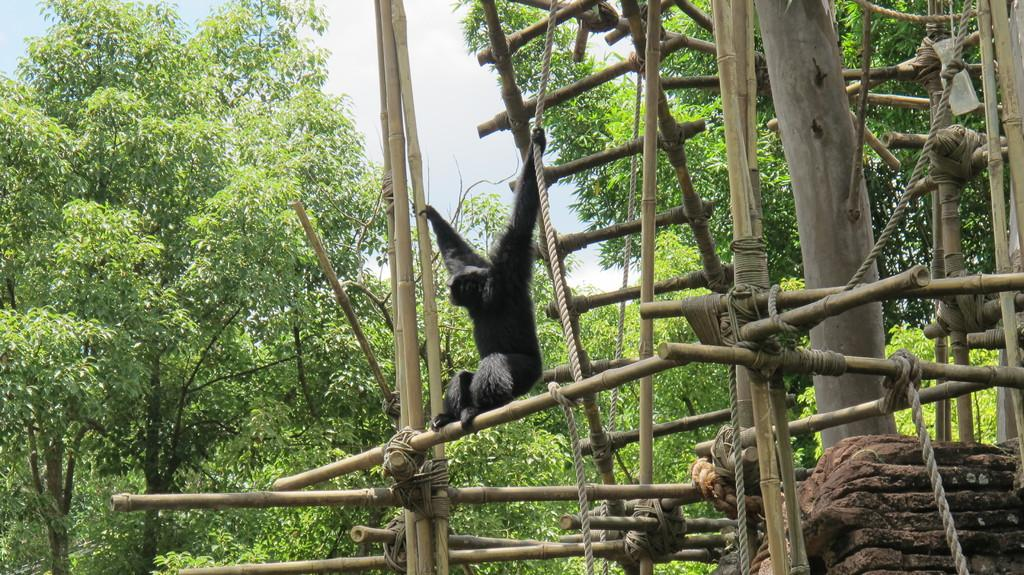What animal is the main subject of the image? There is a gorilla in the image. What is the gorilla doing in the image? The gorilla is sitting on sticks. What is the color of the gorilla? The gorilla is black in color. What can be seen in the background of the image? There are trees in the background of the image. What else is present in the image besides the gorilla and trees? There are many sticks tied along with a rope to the right of the image. Reasoning: Let'g: Let's think step by step in order to produce the conversation. We start by identifying the main subject of the image, which is the gorilla. Then, we describe what the gorilla is doing and its color. Next, we mention the background of the image, which includes trees. Finally, we expand the conversation to include other objects present in the image, such as the sticks tied with a rope. Absurd Question/Answer: What type of tax is being discussed in the image? There is no discussion of tax in the image; it features a gorilla sitting on sticks with trees in the background and sticks tied with a rope to the right. How does the gorilla slip on the wet surface in the image? There is no wet surface or slipping gorilla in the image; the gorilla is sitting on sticks. What is the person in the image holding? The person in the image is holding a camera. Where is the person standing in the image? The person is standing on a bridge. What is the bridge located over in the image? The bridge is over a river. What can be seen in the river in the image? There are boats in the river. What is visible in the background of the image? The sky is visible in the image. Reasoning: Let's think step by step in order to produce the conversation. We start by identifying the main subject of the image, which is the person holding a camera. Then, we describe the person's location, which is on a bridge over a river. Next, we mention the presence of boats in the river and the visibility of the sky in the background. Each question is designed to elicit a specific detail about the image that is known from the provided facts. Absurd Question/Answer: 